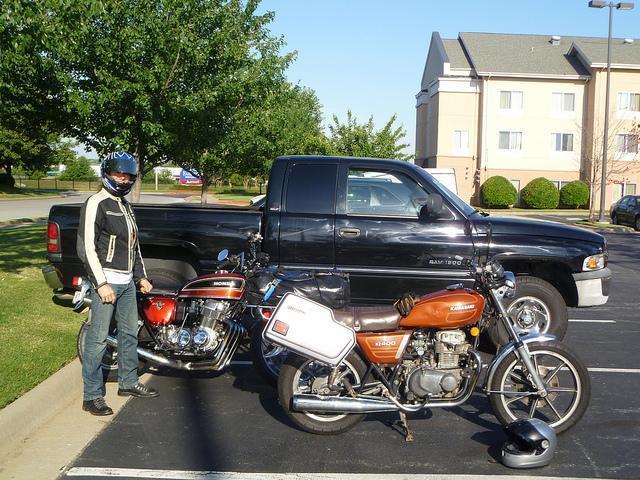How many red motorcycles?
Give a very brief answer. 1. How many motorcycles are there?
Give a very brief answer. 2. How many ski lift chairs are visible?
Give a very brief answer. 0. 